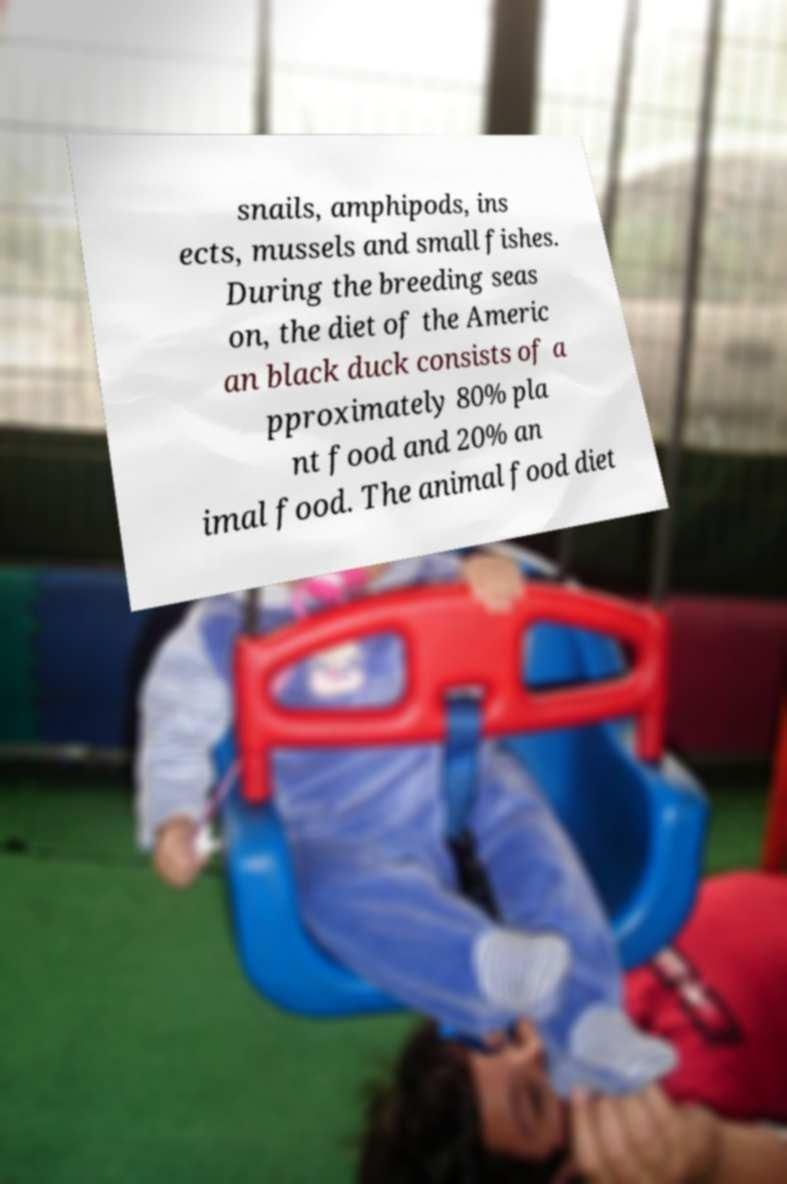There's text embedded in this image that I need extracted. Can you transcribe it verbatim? snails, amphipods, ins ects, mussels and small fishes. During the breeding seas on, the diet of the Americ an black duck consists of a pproximately 80% pla nt food and 20% an imal food. The animal food diet 